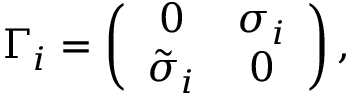Convert formula to latex. <formula><loc_0><loc_0><loc_500><loc_500>\Gamma _ { i } = \left ( \begin{array} { c c } { 0 } & { { \sigma _ { i } } } \\ { { { \tilde { \sigma } } _ { i } } } & { 0 } \end{array} \right ) ,</formula> 